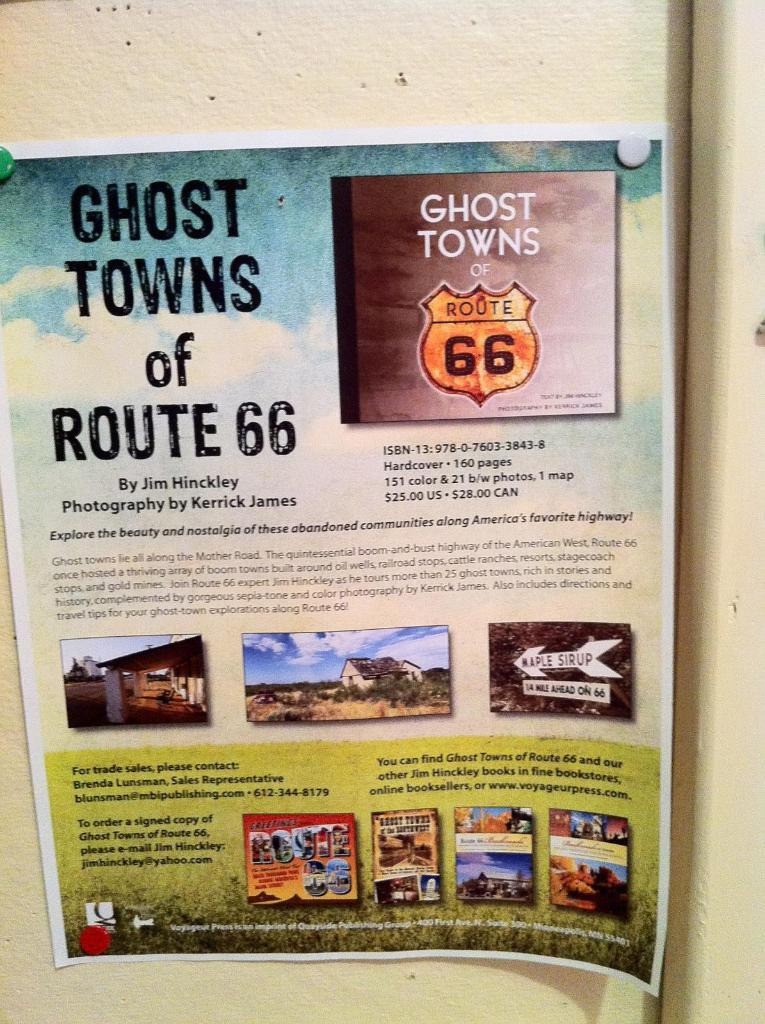<image>
Present a compact description of the photo's key features. A colorful poster advertising a photographic collection of Route 66's ghost towns. 